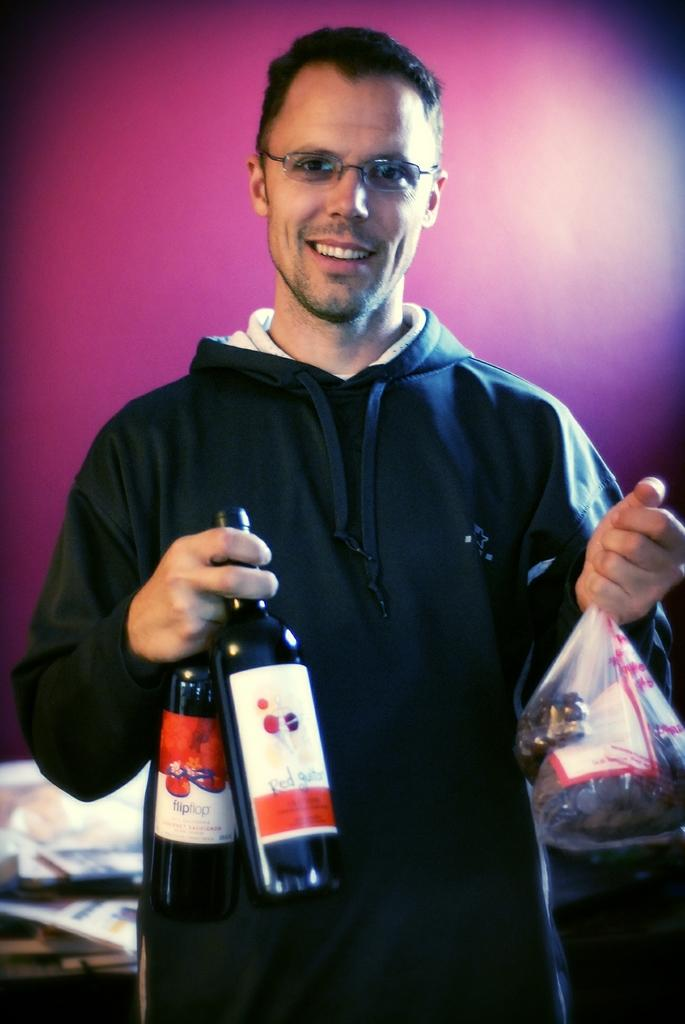Who is present in the image? There is a man in the image. What is the man wearing? The man is wearing a hoodie. What is the man holding in his hands? The man is holding two wine bottles and a cover in his other hand. What type of jar is the man holding in the image? There is no jar present in the image; the man is holding two wine bottles and a cover. What is the man's relationship to the person asking the questions? The provided facts do not give any information about the man's relationship to the person asking the questions, so it cannot be determined. 